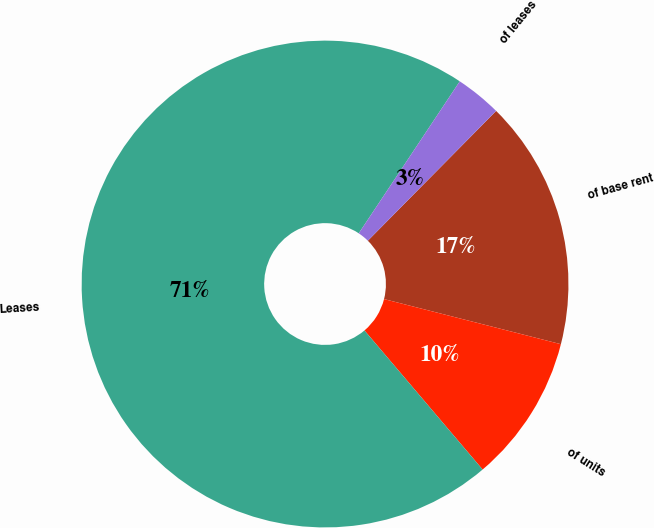Convert chart to OTSL. <chart><loc_0><loc_0><loc_500><loc_500><pie_chart><fcel>of base rent<fcel>of units<fcel>Leases<fcel>of leases<nl><fcel>16.57%<fcel>9.82%<fcel>70.55%<fcel>3.07%<nl></chart> 